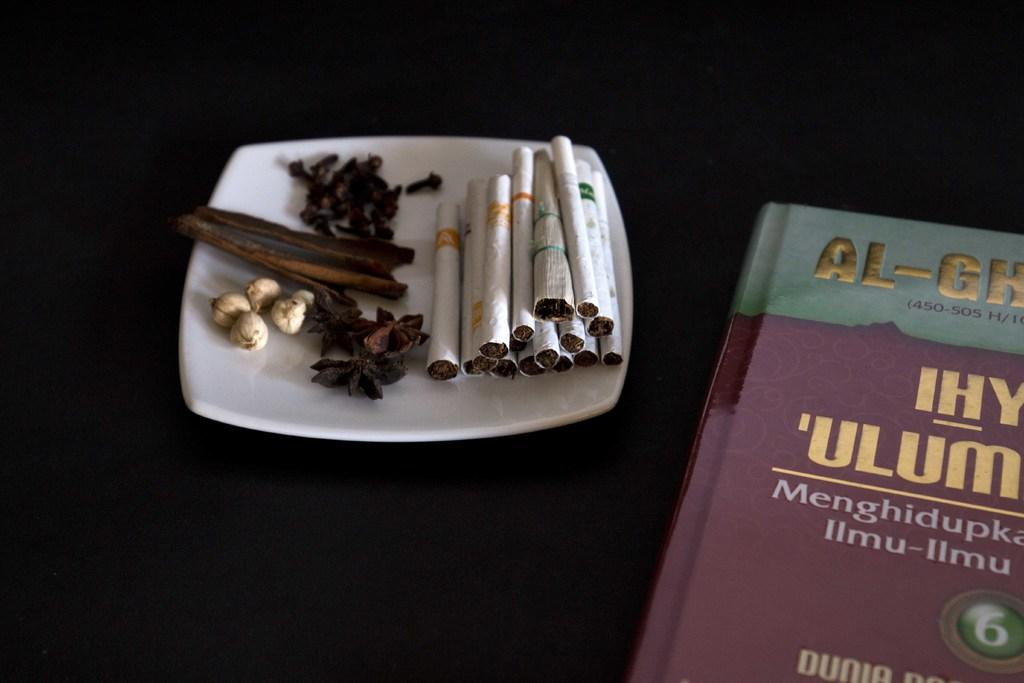<image>
Give a short and clear explanation of the subsequent image. The book has a number 6 encircled in a green circle 